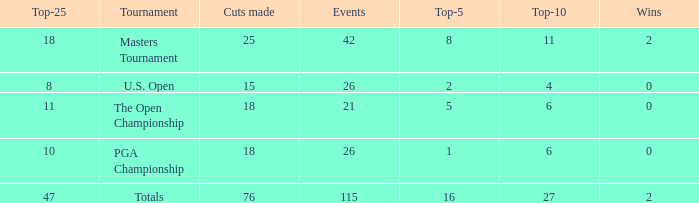Parse the table in full. {'header': ['Top-25', 'Tournament', 'Cuts made', 'Events', 'Top-5', 'Top-10', 'Wins'], 'rows': [['18', 'Masters Tournament', '25', '42', '8', '11', '2'], ['8', 'U.S. Open', '15', '26', '2', '4', '0'], ['11', 'The Open Championship', '18', '21', '5', '6', '0'], ['10', 'PGA Championship', '18', '26', '1', '6', '0'], ['47', 'Totals', '76', '115', '16', '27', '2']]} What are the largest cuts made when the events are less than 21? None. 